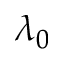Convert formula to latex. <formula><loc_0><loc_0><loc_500><loc_500>\lambda _ { 0 }</formula> 